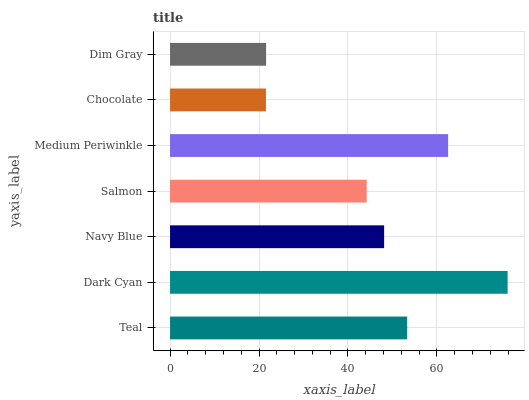Is Chocolate the minimum?
Answer yes or no. Yes. Is Dark Cyan the maximum?
Answer yes or no. Yes. Is Navy Blue the minimum?
Answer yes or no. No. Is Navy Blue the maximum?
Answer yes or no. No. Is Dark Cyan greater than Navy Blue?
Answer yes or no. Yes. Is Navy Blue less than Dark Cyan?
Answer yes or no. Yes. Is Navy Blue greater than Dark Cyan?
Answer yes or no. No. Is Dark Cyan less than Navy Blue?
Answer yes or no. No. Is Navy Blue the high median?
Answer yes or no. Yes. Is Navy Blue the low median?
Answer yes or no. Yes. Is Medium Periwinkle the high median?
Answer yes or no. No. Is Teal the low median?
Answer yes or no. No. 